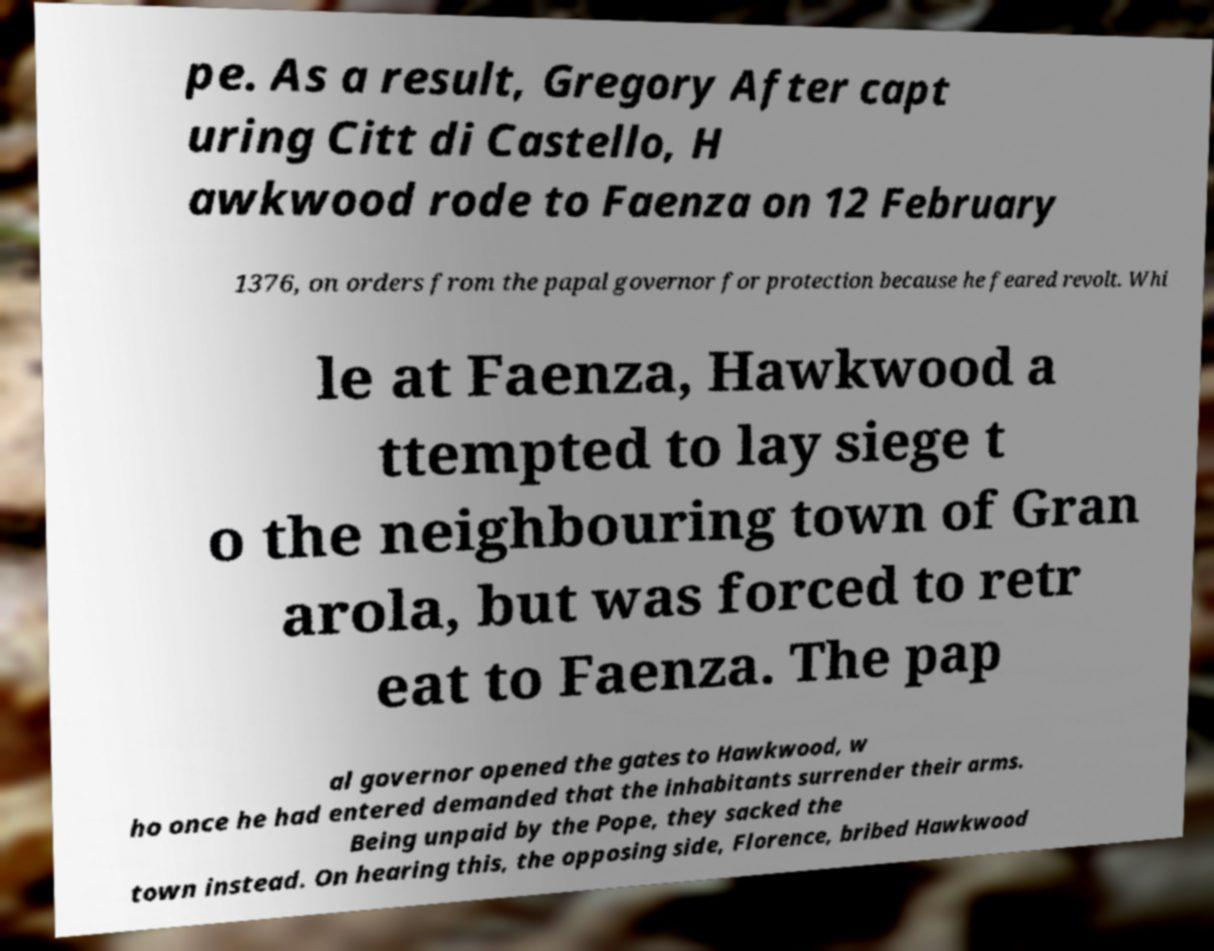I need the written content from this picture converted into text. Can you do that? pe. As a result, Gregory After capt uring Citt di Castello, H awkwood rode to Faenza on 12 February 1376, on orders from the papal governor for protection because he feared revolt. Whi le at Faenza, Hawkwood a ttempted to lay siege t o the neighbouring town of Gran arola, but was forced to retr eat to Faenza. The pap al governor opened the gates to Hawkwood, w ho once he had entered demanded that the inhabitants surrender their arms. Being unpaid by the Pope, they sacked the town instead. On hearing this, the opposing side, Florence, bribed Hawkwood 